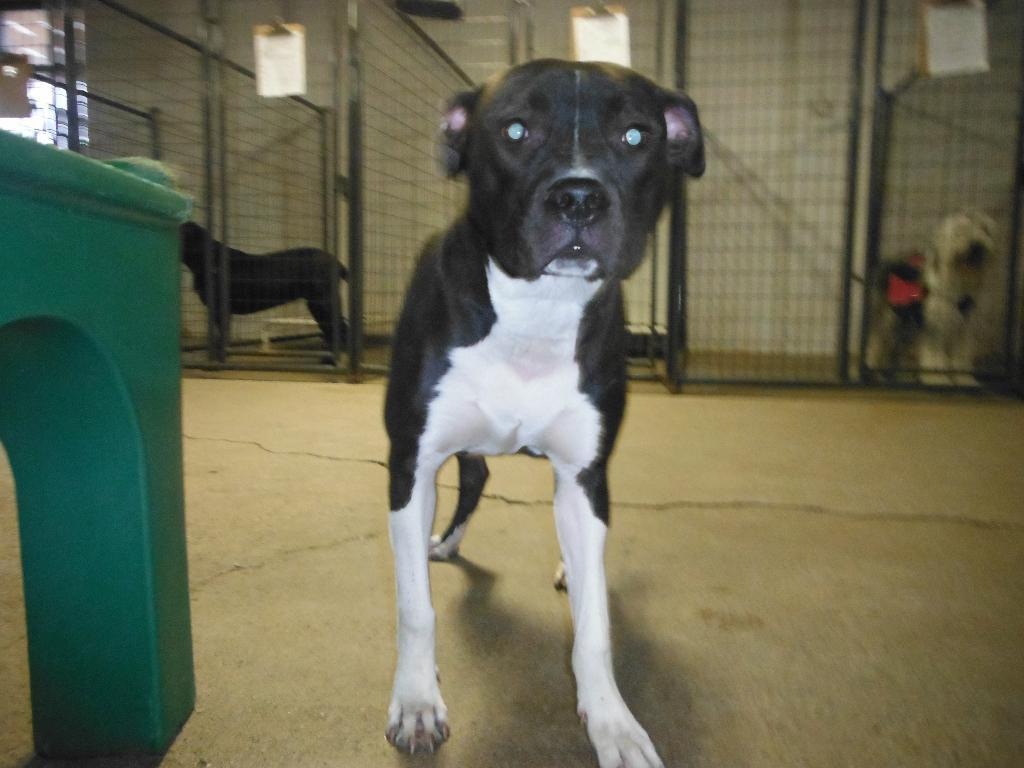What type of animals can be seen in the image? There are dogs in the image. What objects are present in the image? There are boards and a bench visible in the image. What can be used for cooking in the image? There are grills visible in the image. How many rabbits can be seen in the image? There are no rabbits present in the image; it features dogs, boards, a bench, and grills. What type of box is used to increase the size of the dogs in the image? There is no box or any method mentioned in the image to increase the size of the dogs. 